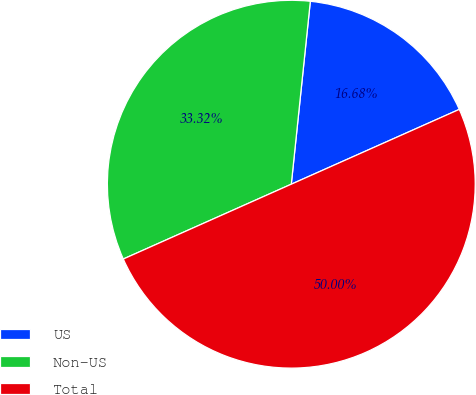<chart> <loc_0><loc_0><loc_500><loc_500><pie_chart><fcel>US<fcel>Non-US<fcel>Total<nl><fcel>16.68%<fcel>33.32%<fcel>50.0%<nl></chart> 